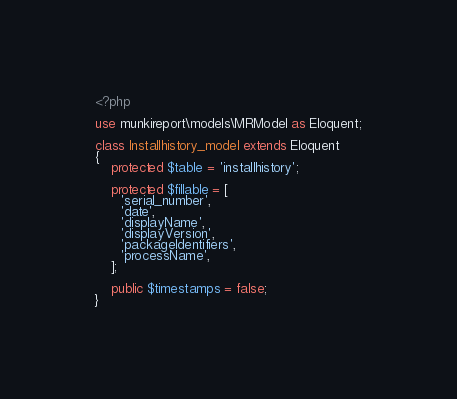Convert code to text. <code><loc_0><loc_0><loc_500><loc_500><_PHP_><?php

use munkireport\models\MRModel as Eloquent;

class Installhistory_model extends Eloquent
{
    protected $table = 'installhistory';

    protected $fillable = [
      'serial_number',
      'date',
      'displayName',
      'displayVersion',
      'packageIdentifiers',
      'processName',
    ];

    public $timestamps = false;
}
</code> 